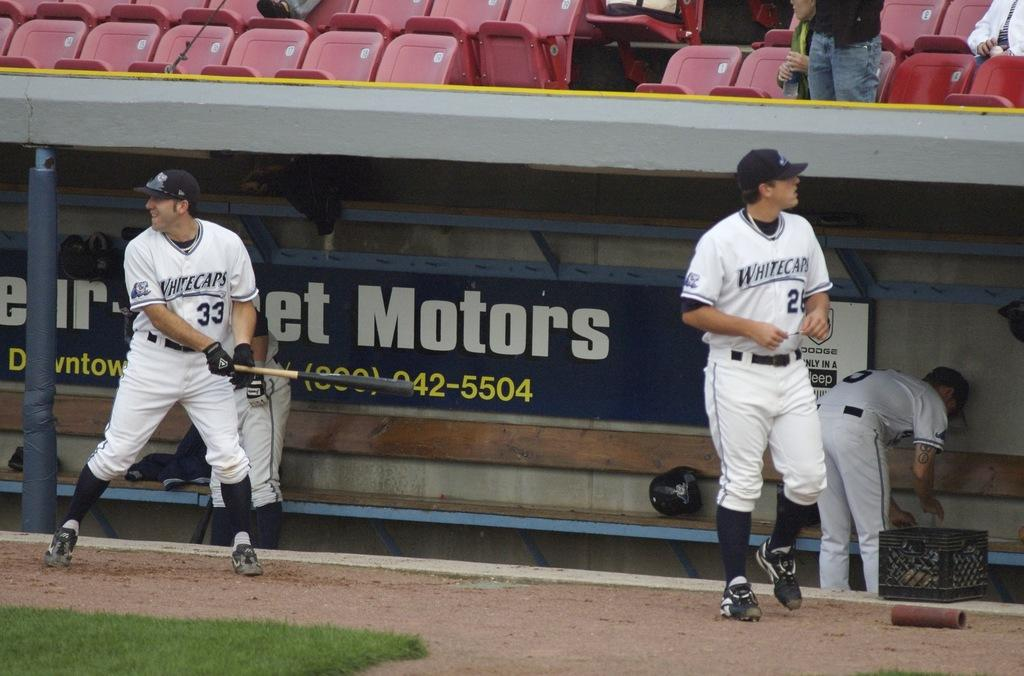How many people are on the ground and grass in the image? There are four persons on the ground and grass in the image. What can be seen in the background of the image? In the background of the image, there is a fence, boards, and a group of people on seats. What time of day was the image taken? The image was taken during the day. What type of animal is being operated on in the image? There is no operation or animal present in the image. 